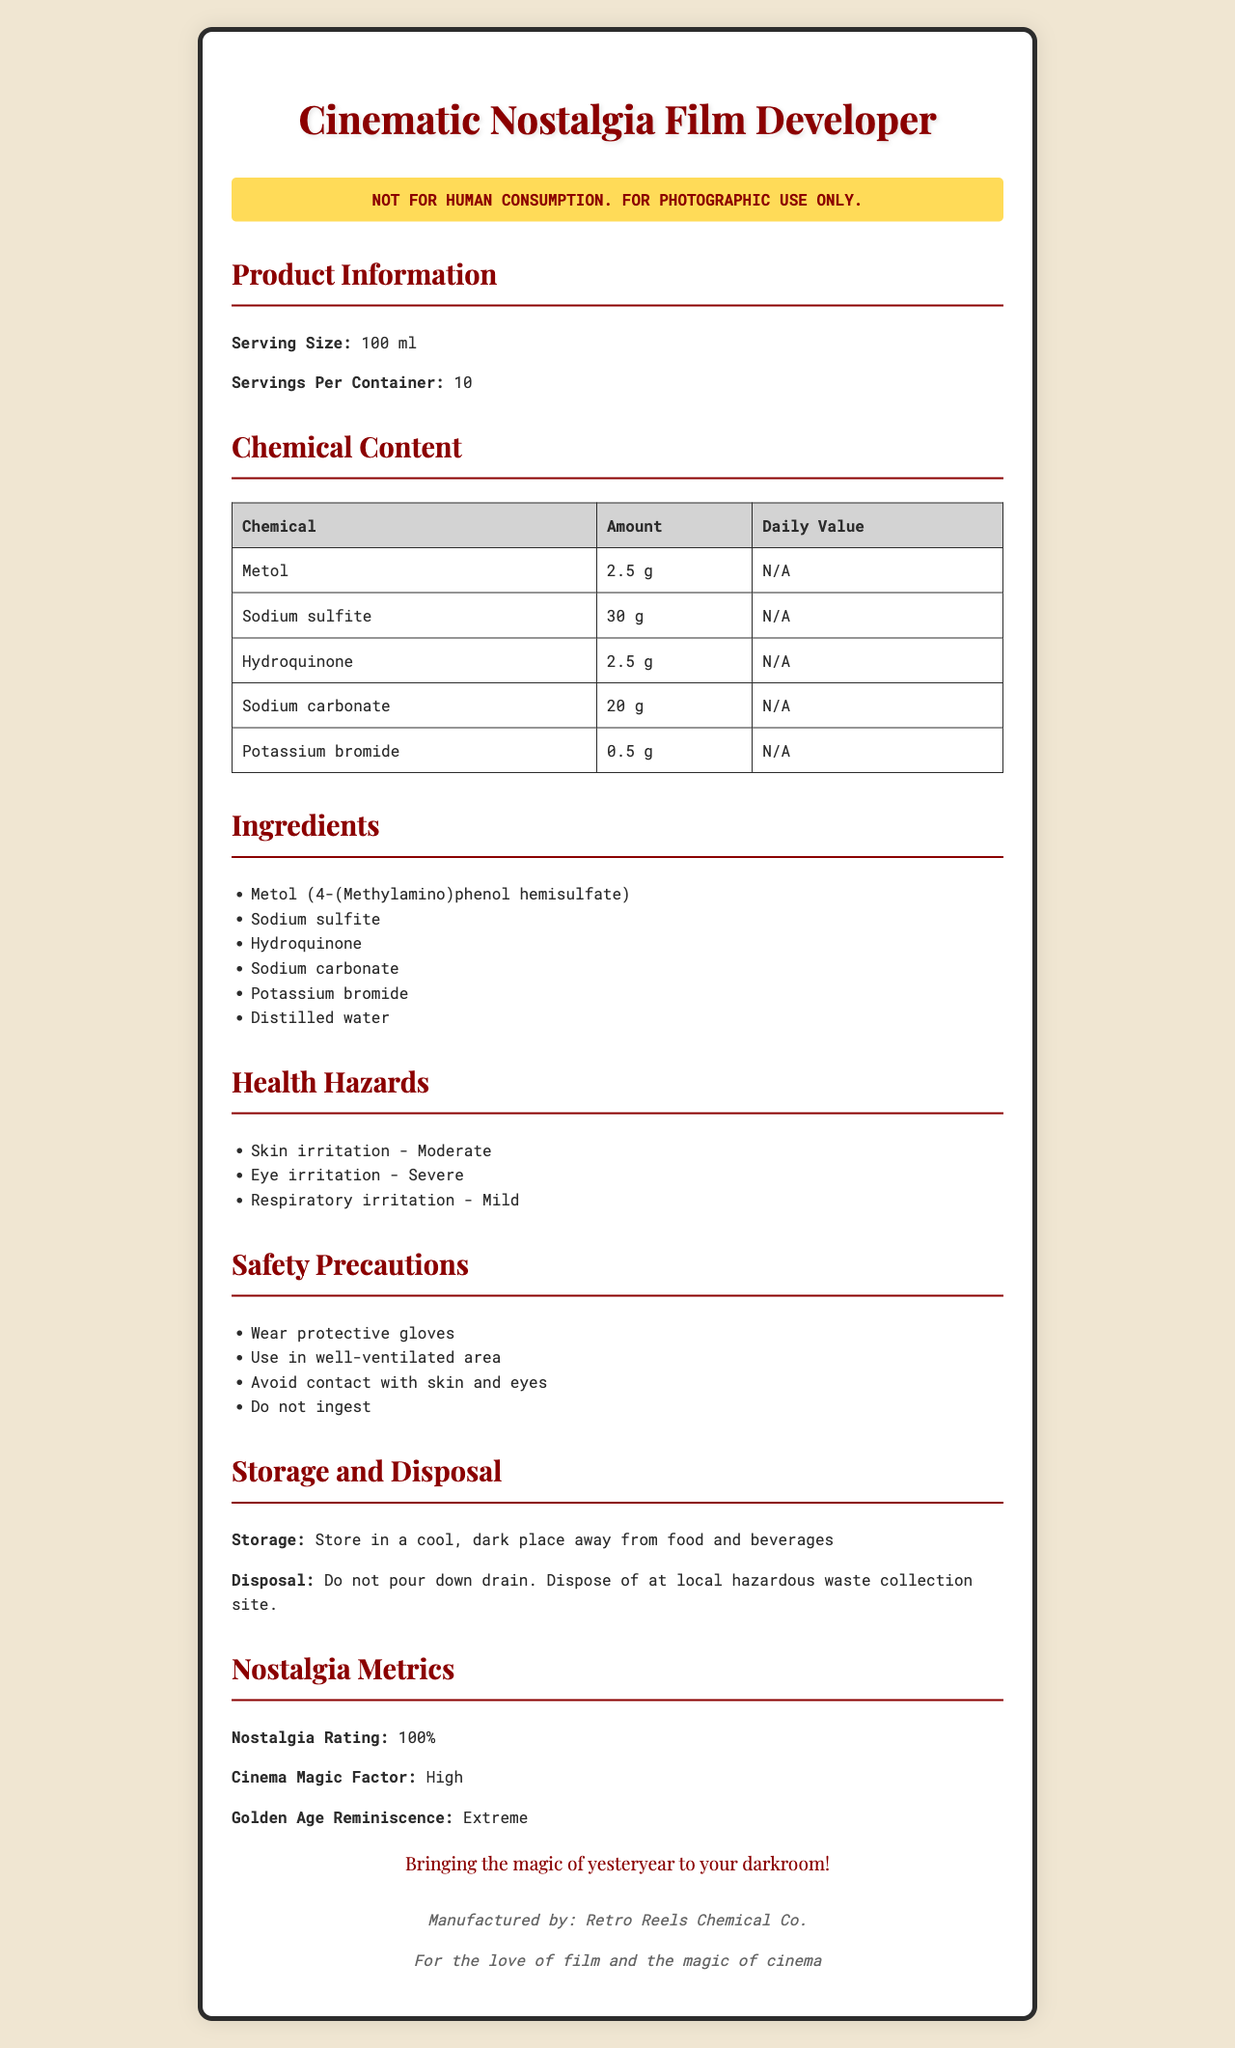what is the name of the product? The name of the product is stated at the top of the document and highlighted.
Answer: Cinematic Nostalgia Film Developer how many servings are in one container? The document specifies "Servings Per Container: 10".
Answer: 10 what are the main ingredients of the product? The ingredients are listed under the "Ingredients" section.
Answer: Metol, Sodium sulfite, Hydroquinone, Sodium carbonate, Potassium bromide, Distilled water what is the amount of Sodium carbonate per serving? The amount of Sodium carbonate is listed in the "Chemical Content" table.
Answer: 20 g what is the warning associated with this product? The warning is exactly stated in a special highlighted section on the document.
Answer: NOT FOR HUMAN CONSUMPTION. FOR PHOTOGRAPHIC USE ONLY. which of the following is a health hazard of the product? A. Hair loss B. Skin irritation C. Tooth decay D. Nausea In the "Health Hazards" section, skin irritation is one of the listed hazards.
Answer: B how should this product be stored? A. At room temperature B. In a freezer C. In a cool, dark place away from food and beverages The storage instructions are specified under "Storage and Disposal" section.
Answer: C which company manufactures the product? A. Old Cinema Chemicals B. Retro Reels Chemical Co. C. Nostalgic Film Industry D. Timeless Film Corp. The manufacturer "Retro Reels Chemical Co." is mentioned in the footer of the document.
Answer: B should you ingest this product? The warning clearly states, "Do not ingest."
Answer: No summarize the key points of this document. The document primarily focuses on the product name, its non-edible nature, health hazards, safety precautions, storage, and disposal instructions, while also emphasizing its cinematic nostalgia.
Answer: This document provides the nutrition facts and safety information for the "Cinematic Nostalgia Film Developer." It warns against human consumption and lists chemical ingredients like Metol and Sodium sulfite. It details potential health hazards, safety precautions, and guidelines for storage and disposal. The product is manufactured by Retro Reels Chemical Co. and evokes nostalgia for classic cinema. what is the nutritional daily value of Hydroquinone? The "Chemical Content" table shows "N/A" under the daily value for Hydroquinone.
Answer: Not applicable how many grams of Metol does one serving contain? The "Chemical Content" table specifies that a serving contains 2.5 g of Metol.
Answer: 2.5 g is the cinema magic factor of this product high? The document states that the "Cinema Magic Factor" is "High."
Answer: Yes how many types of health hazards are listed in the document? There are three health hazards listed: Skin irritation, Eye irritation, and Respiratory irritation.
Answer: 3 how often should you use this product to develop black-and-white films? The document does not specify the frequency or amount needed for film development.
Answer: Not enough information 